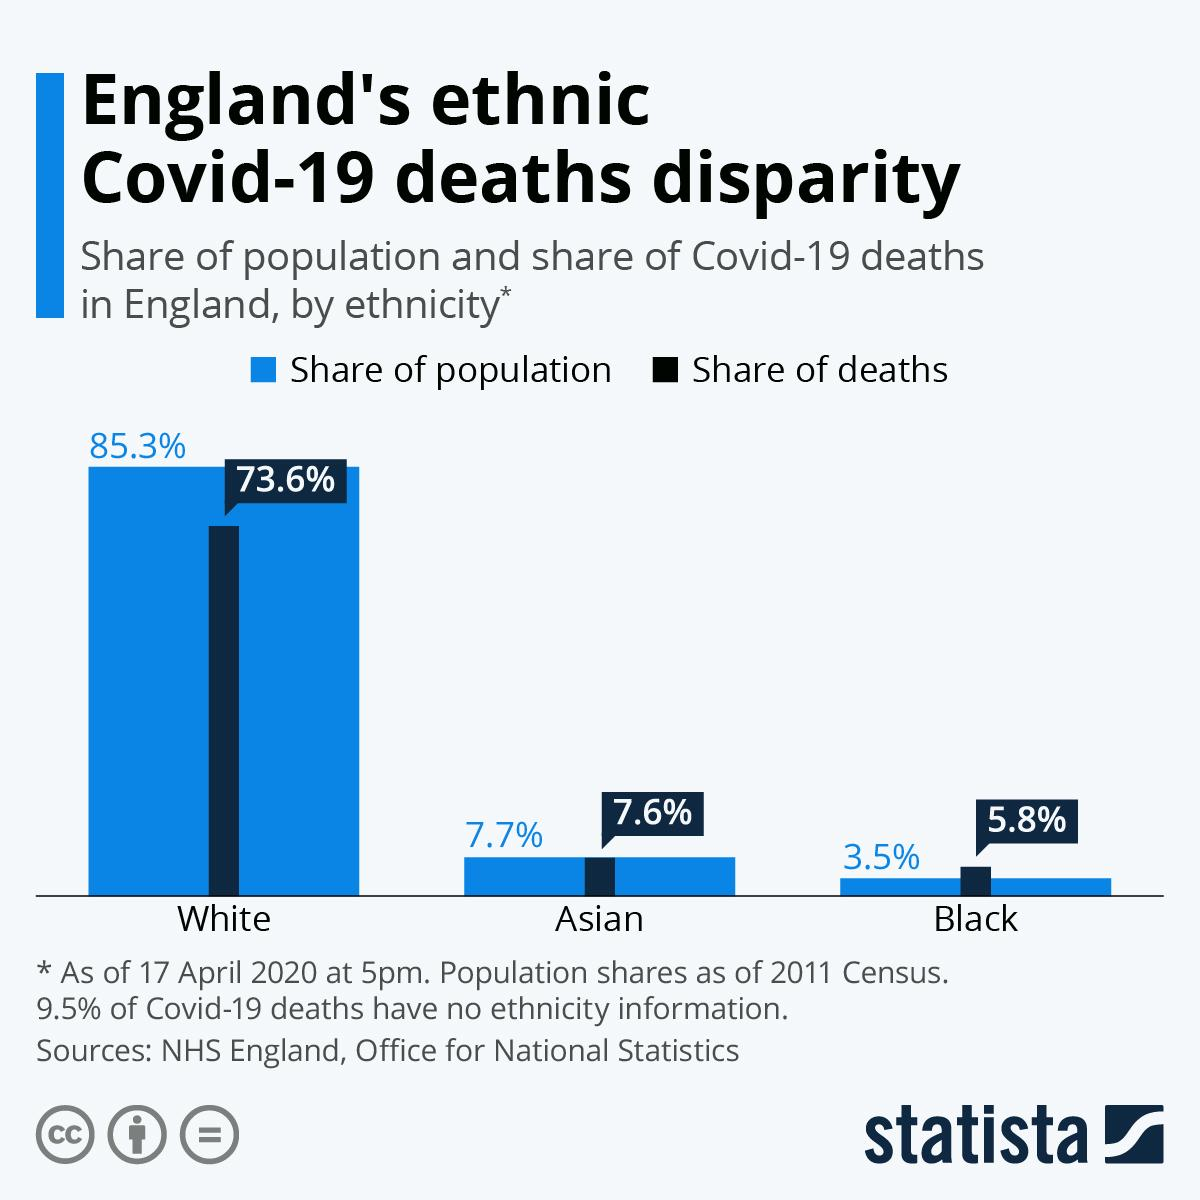Mention a couple of crucial points in this snapshot. For which ethnicity does the share of population In England, it is estimated that 5.8% of the population who are Black have died. The Black population in England represents approximately 3.5% of the overall population. According to the data, 7.6% of the people who died in England were Asian. The color typically associated with the share of population is blue. 